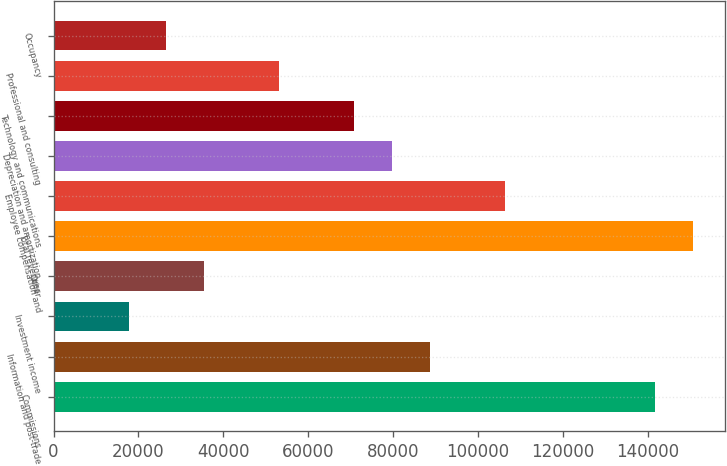<chart> <loc_0><loc_0><loc_500><loc_500><bar_chart><fcel>Commissions<fcel>Information and post-trade<fcel>Investment income<fcel>Other<fcel>Total revenues<fcel>Employee compensation and<fcel>Depreciation and amortization<fcel>Technology and communications<fcel>Professional and consulting<fcel>Occupancy<nl><fcel>141716<fcel>88573<fcel>17715.2<fcel>35429.7<fcel>150574<fcel>106287<fcel>79715.8<fcel>70858.5<fcel>53144.1<fcel>26572.4<nl></chart> 